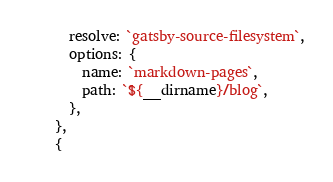Convert code to text. <code><loc_0><loc_0><loc_500><loc_500><_JavaScript_>      resolve: `gatsby-source-filesystem`,
      options: {
        name: `markdown-pages`,
        path: `${__dirname}/blog`,
      },
    },
    {</code> 